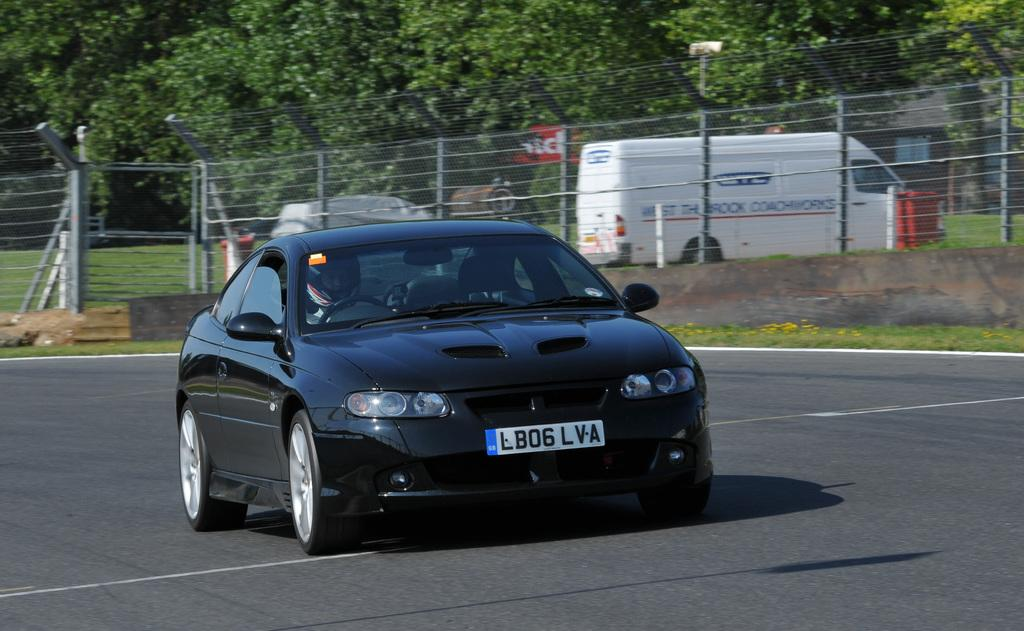What is the person in the image doing? The person is riding a car in the image. Where is the car located? The car is on the road in the image. What can be seen in the background of the image? There are trees, fencing, grass, a vehicle, and some objects in the background of the image. Can you see a harbor in the image? No, there is no harbor present in the image. Is the person using a quill to write while riding the car? No, there is no quill or writing activity depicted in the image. 